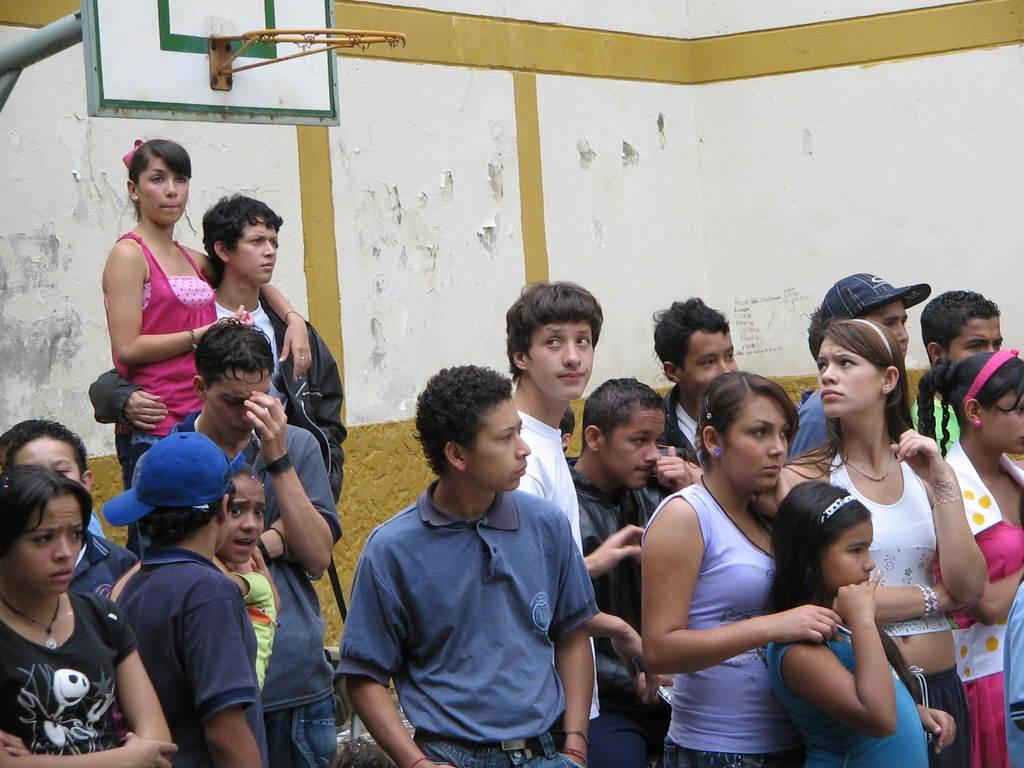What is happening in the image involving the group of people? There is a group of people standing in the image, and a man and a woman are holding each other. What can be seen in the background of the image? There is a goal post and a wall visible in the image. What type of letters are being exchanged between the people in the image? There are no letters being exchanged in the image; it features a group of people standing and interacting with each other. What part of the human body is visible in the image? The image does not show any specific part of the human body; it focuses on the group of people and their interaction. 